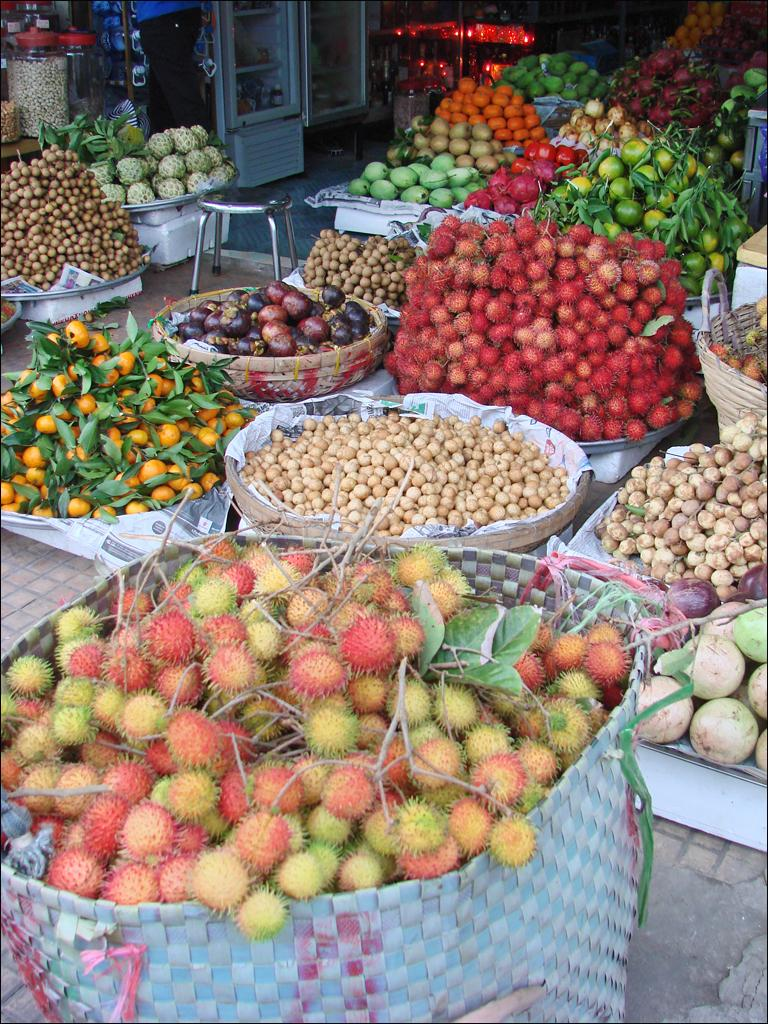What objects are present in the image that can hold items? There are baskets in the image that can hold items. What types of items are contained within the baskets? The baskets contain fruits and vegetables. Where are the jars located in the image? The jars are on the top left side of the image. What hobbies are being discussed at the meeting in the image? There is no meeting or discussion of hobbies present in the image; it only features baskets containing fruits and vegetables, and jars on the top left side. 